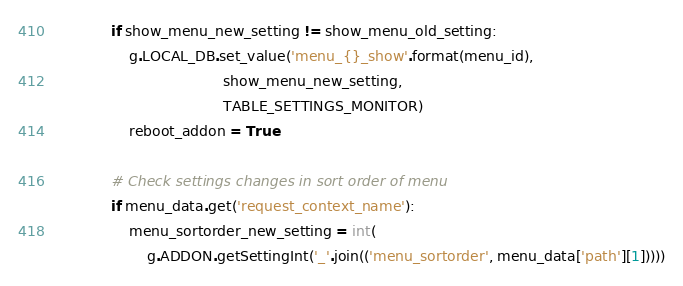<code> <loc_0><loc_0><loc_500><loc_500><_Python_>            if show_menu_new_setting != show_menu_old_setting:
                g.LOCAL_DB.set_value('menu_{}_show'.format(menu_id),
                                     show_menu_new_setting,
                                     TABLE_SETTINGS_MONITOR)
                reboot_addon = True

            # Check settings changes in sort order of menu
            if menu_data.get('request_context_name'):
                menu_sortorder_new_setting = int(
                    g.ADDON.getSettingInt('_'.join(('menu_sortorder', menu_data['path'][1]))))</code> 